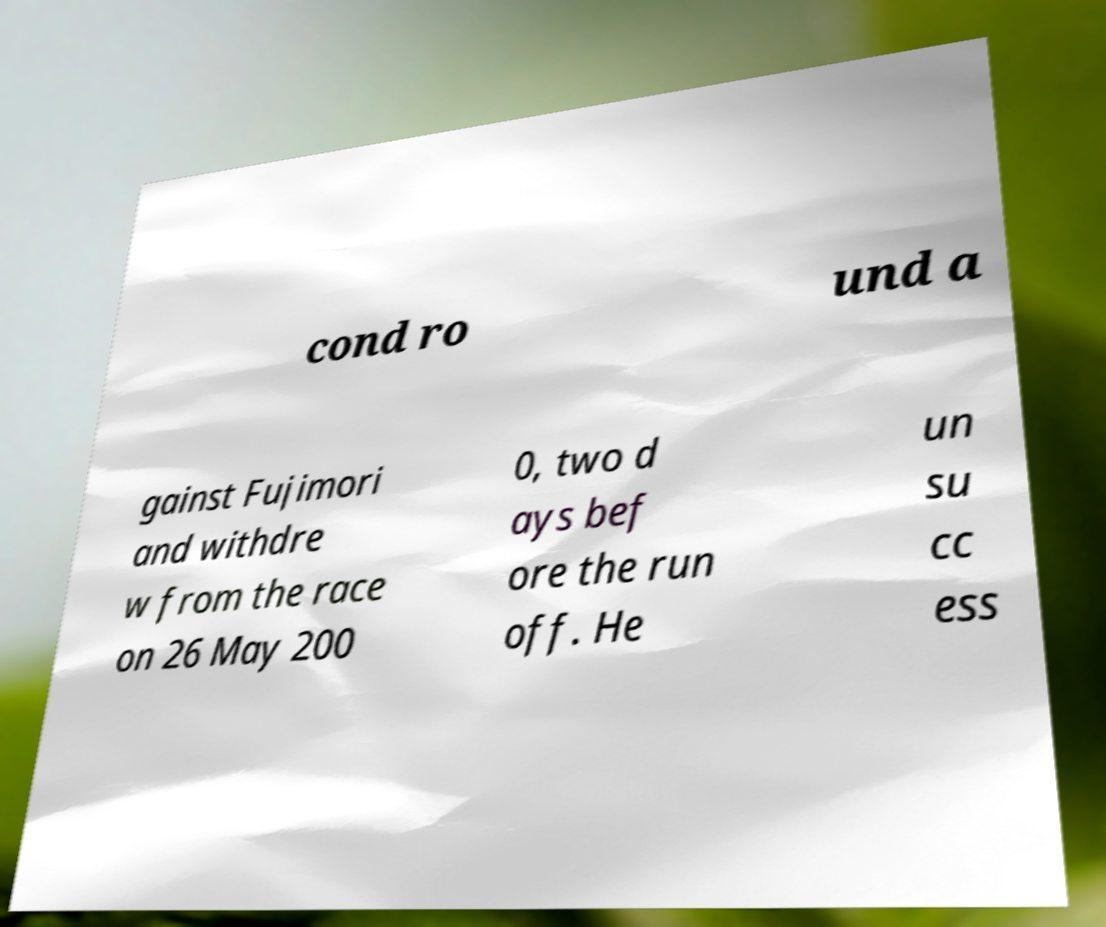Can you read and provide the text displayed in the image?This photo seems to have some interesting text. Can you extract and type it out for me? cond ro und a gainst Fujimori and withdre w from the race on 26 May 200 0, two d ays bef ore the run off. He un su cc ess 